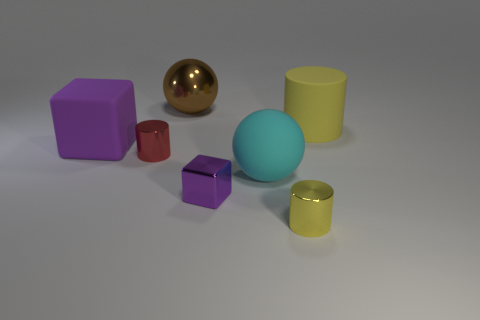If the objects in the image were part of a game, what sort of game could it be? If these objects were part of a game, it could be a puzzle or sorting game where the goal is to organize the shapes by color, size, or type. Another possibility is a physics-based game where players must strategically place or stack the objects without them toppling over, taking advantage of the different sizes and weights implied by the shapes. 